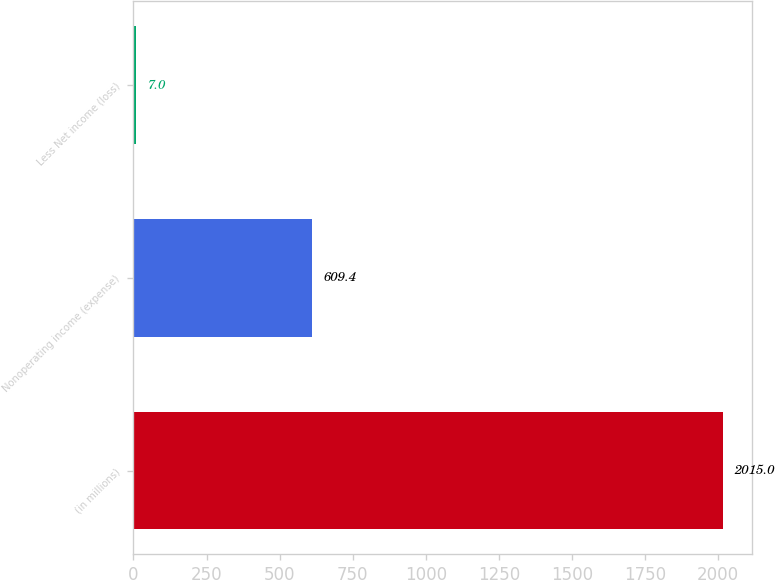Convert chart to OTSL. <chart><loc_0><loc_0><loc_500><loc_500><bar_chart><fcel>(in millions)<fcel>Nonoperating income (expense)<fcel>Less Net income (loss)<nl><fcel>2015<fcel>609.4<fcel>7<nl></chart> 